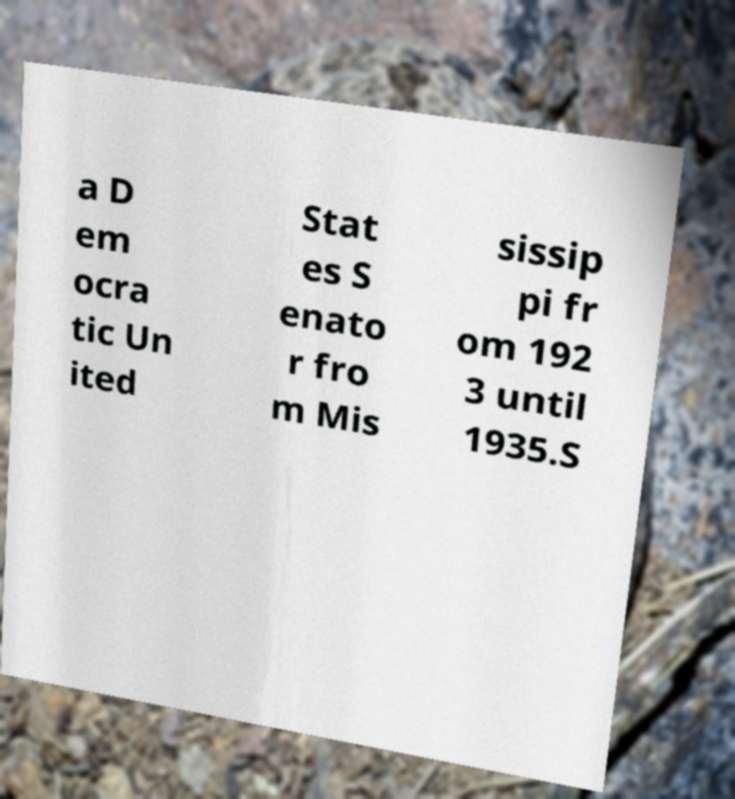Please identify and transcribe the text found in this image. a D em ocra tic Un ited Stat es S enato r fro m Mis sissip pi fr om 192 3 until 1935.S 